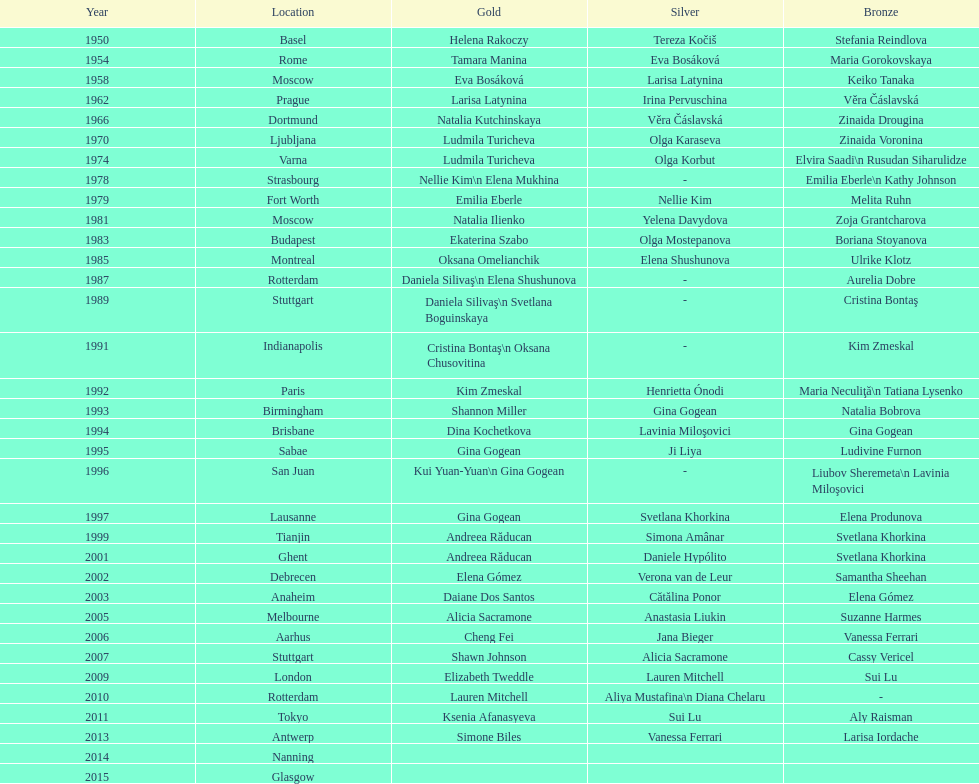How many consecutive floor exercise gold medals did romanian star andreea raducan win at the world championships? 2. 